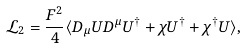<formula> <loc_0><loc_0><loc_500><loc_500>\mathcal { L } _ { 2 } = \frac { F ^ { 2 } } { 4 } \langle D _ { \mu } U D ^ { \mu } U ^ { \dagger } + \chi U ^ { \dagger } + \chi ^ { \dagger } U \rangle ,</formula> 